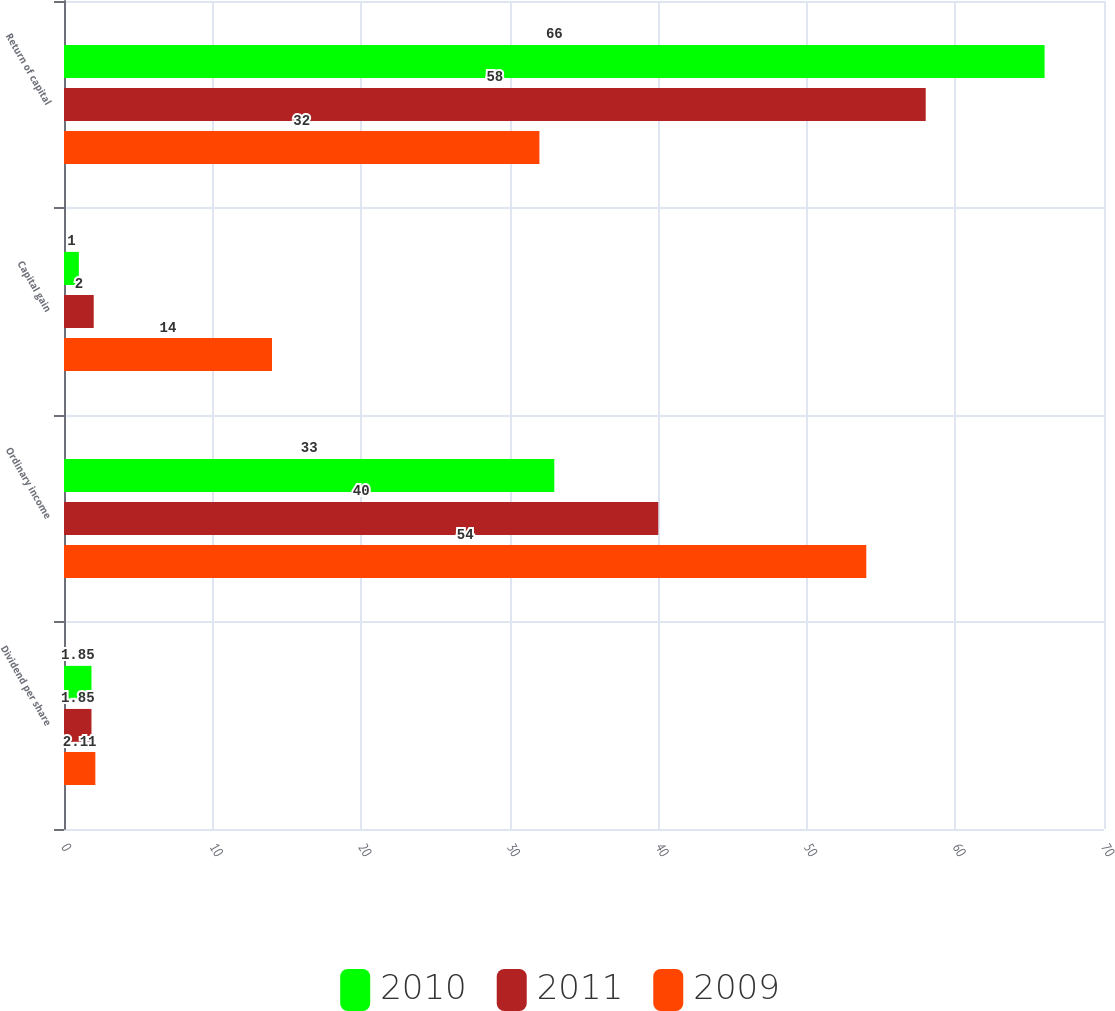Convert chart. <chart><loc_0><loc_0><loc_500><loc_500><stacked_bar_chart><ecel><fcel>Dividend per share<fcel>Ordinary income<fcel>Capital gain<fcel>Return of capital<nl><fcel>2010<fcel>1.85<fcel>33<fcel>1<fcel>66<nl><fcel>2011<fcel>1.85<fcel>40<fcel>2<fcel>58<nl><fcel>2009<fcel>2.11<fcel>54<fcel>14<fcel>32<nl></chart> 